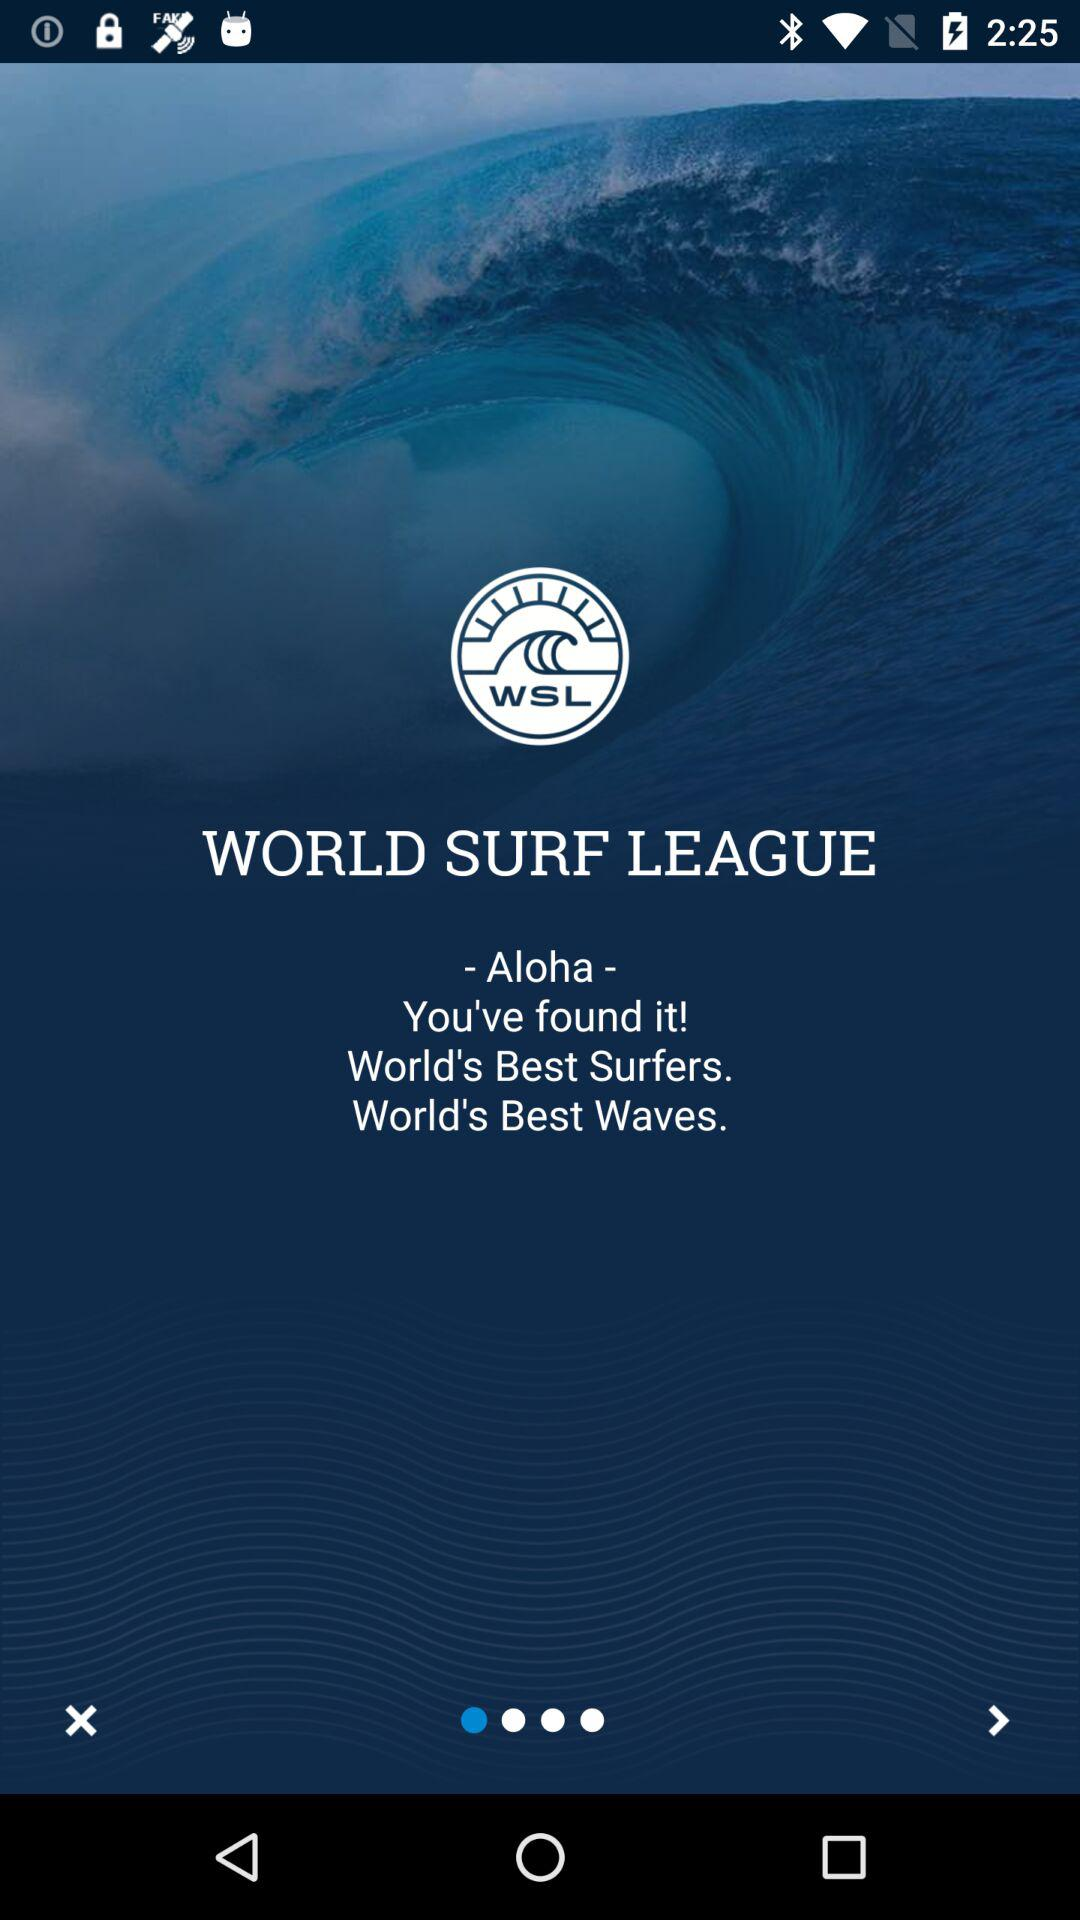Which version of "WSL" is this?
When the provided information is insufficient, respond with <no answer>. <no answer> 